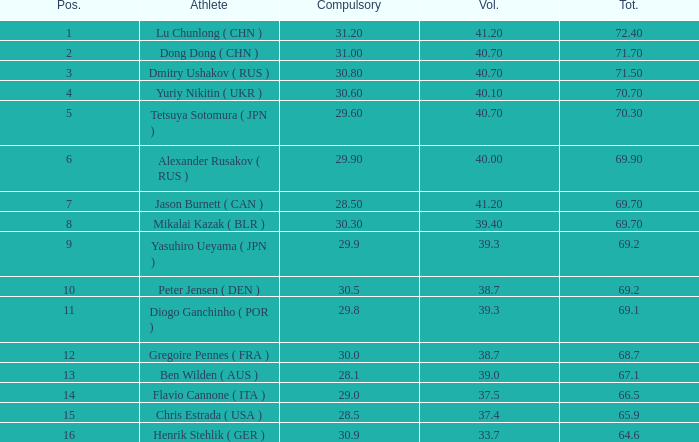What's the total compulsory when the total is more than 69.2 and the voluntary is 38.7? 0.0. 